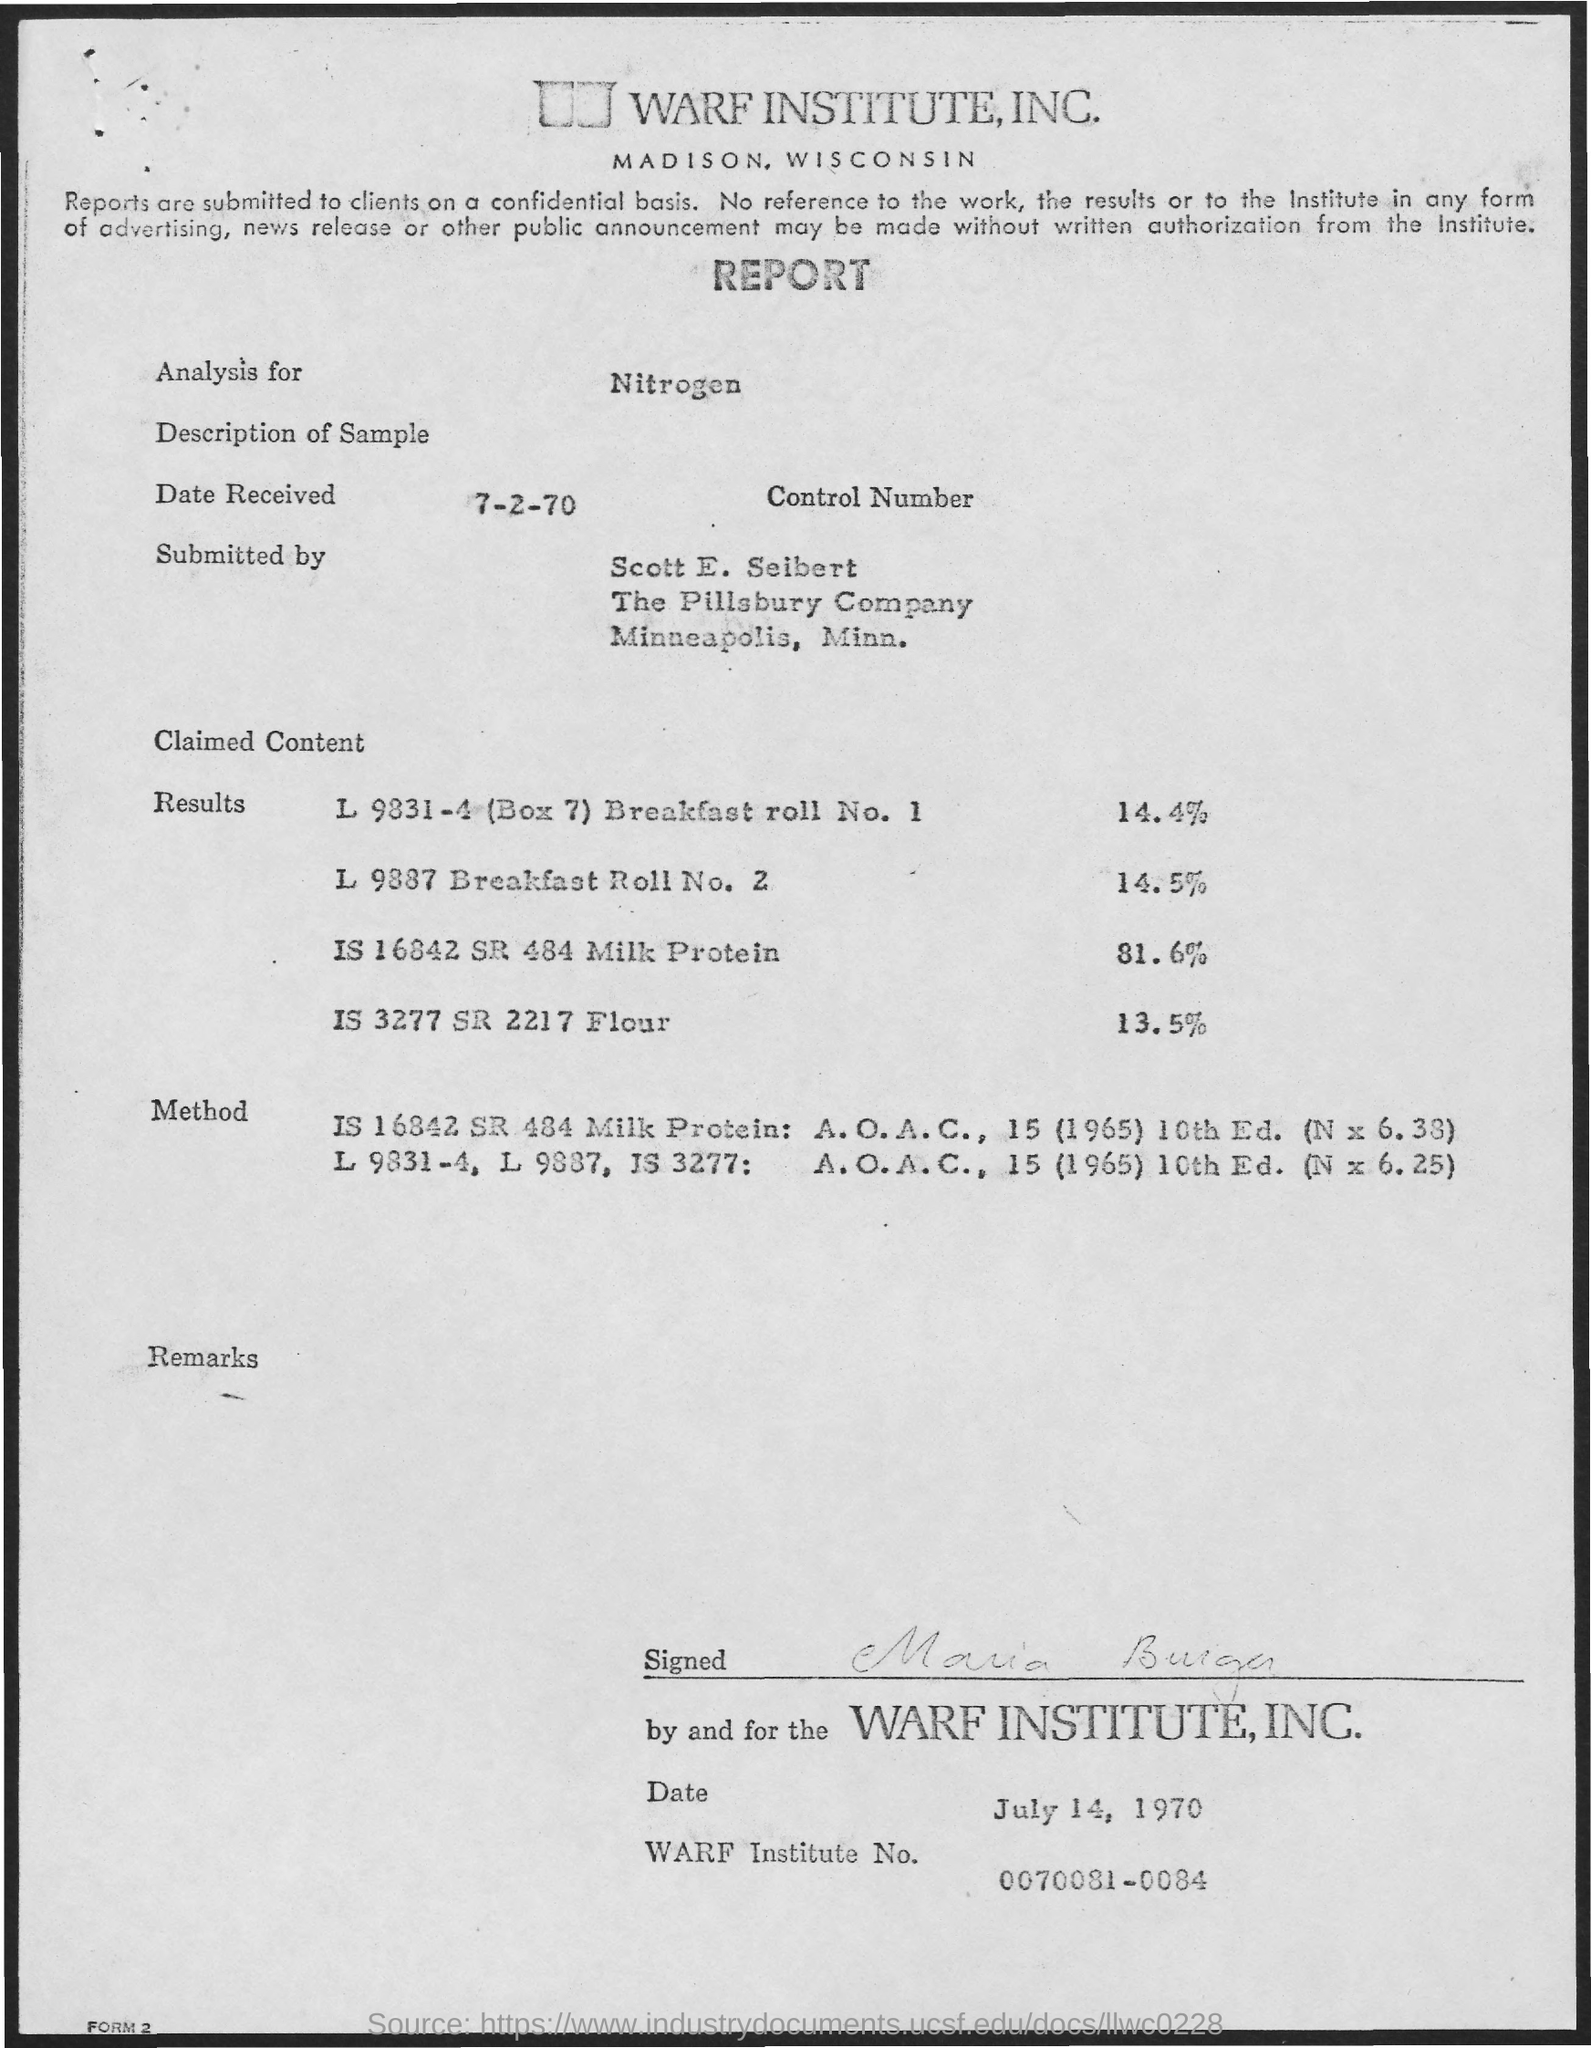Give some essential details in this illustration. The Warf Institute is the name of the institute. The Warf Institute number is 0070081-0084. On July 2nd, 1970, the date received was 7-2-70. 